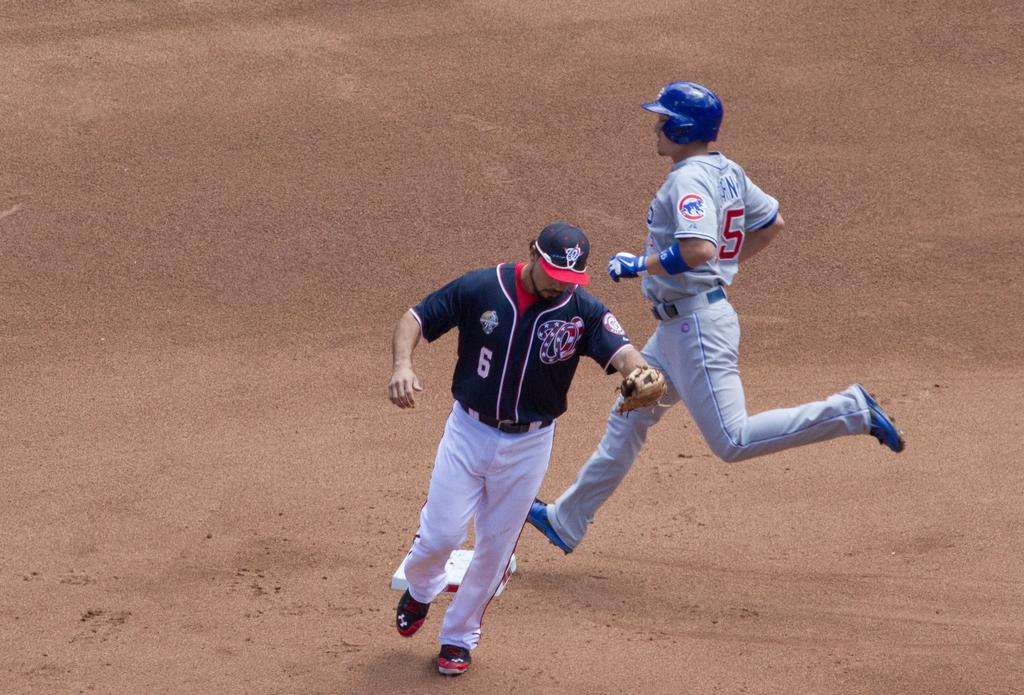<image>
Describe the image concisely. Baseball players number 5 and 6 race around the dirt field 